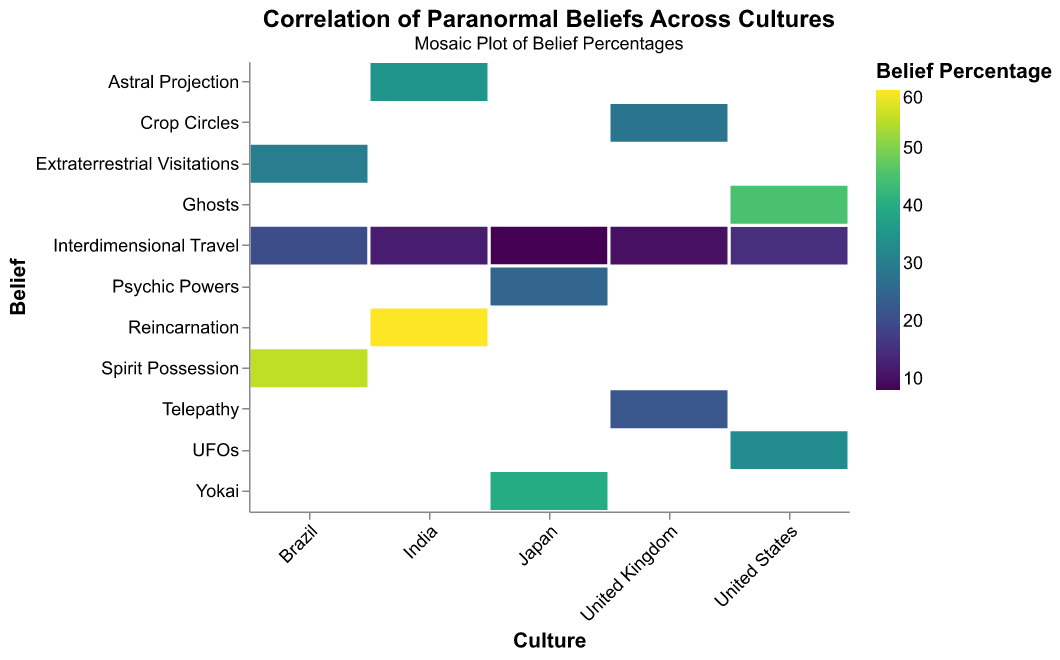What's the highest percentage belief in any culture? The highest percentage belief can be found by examining the color intensity and the numbers on the figure, specifically looking for the darkest or most intense color block. In this case, the highest belief percentage is spirit possession in Brazil, which is 55%.
Answer: 55% Which culture has the lowest belief in interdimensional travel? To determine the culture with the lowest belief in interdimensional travel, look at the interdimensional travel row and identify the smallest percentage. Japan has the lowest belief in interdimensional travel at 8%.
Answer: Japan How does the belief in UFOs in the United States compare to the belief in Yokai in Japan? Find the percentage for UFOs in the United States and Yokai in Japan. UFOs in the United States are believed by 33% of people, while Yokai in Japan are believed by 40%.
Answer: Yokai in Japan is higher What is the average belief percentage of interdimensional travel across all cultures? Calculate the average belief percentage of interdimensional travel by summing the percentages (15 + 8 + 20 + 12 + 10) and dividing by the number of cultures (5). The sum is 65, and the average is 65/5, which equals 13%.
Answer: 13% Which culture has the highest belief in a paranormal phenomenon other than interdimensional travel? To find this, look at each culture and ignore the interdimensional travel row. Identify the highest percentage in any other belief. Brazil has the highest belief in spirit possession at 55%.
Answer: Brazil In which culture is the belief in interdimensional travel closest to the belief in UFOs? Compare the percentages of interdimensional travel and UFOs for each culture. In the United States, the belief in interdimensional travel is 15%, and the belief in UFOs is 33%. The closest match is found by calculating the absolute difference, with the smallest difference being between these two values. Thus, the United States has the closest match (difference of 18).
Answer: United States What is the difference between the belief in psychic powers in Japan and telepathy in the United Kingdom? Look at the figure to find the belief percentages for psychic powers in Japan (25%) and telepathy in the United Kingdom (22%). The difference is calculated by subtracting the smaller number from the larger one, which is 3%.
Answer: 3% Considering only spirits (ghosts, yokai, spirit possession), which culture has the highest average belief? First, find the relevant belief percentages for each culture: United States (Ghosts 45%), Japan (Yokai 40%), Brazil (Spirit Possession 55%), India (none), United Kingdom (none). Then, average these values for each culture with data. For the United States, it’s 45%; for Japan, it’s 40%; for Brazil, it’s 55%. Thus, Brazil has the highest average belief in spirits.
Answer: Brazil What is the sum total of the belief percentages for paranormal phenomena in India? Add the percentages of all beliefs in India: Interdimensional Travel (12%), Reincarnation (60%), Astral Projection (35%). The sum is 12 + 60 + 35, which equals 107%.
Answer: 107% What is the proportion of belief in crop circles to belief in telepathy in the United Kingdom? Divide the percentage of belief in crop circles (28%) by the belief in telepathy (22%) to find the proportion. 28/22 is approximately 1.27.
Answer: ~1.27 